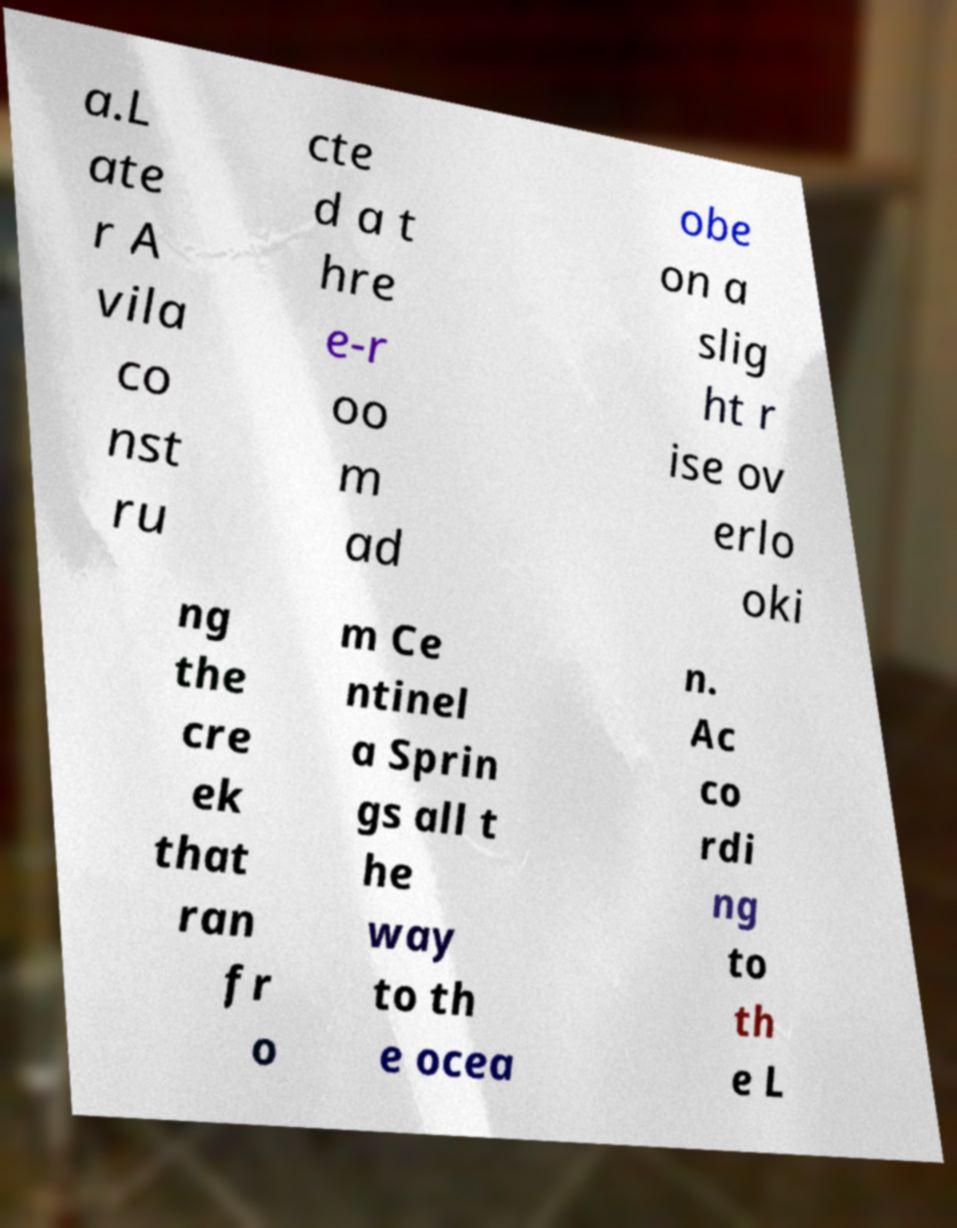Can you accurately transcribe the text from the provided image for me? a.L ate r A vila co nst ru cte d a t hre e-r oo m ad obe on a slig ht r ise ov erlo oki ng the cre ek that ran fr o m Ce ntinel a Sprin gs all t he way to th e ocea n. Ac co rdi ng to th e L 